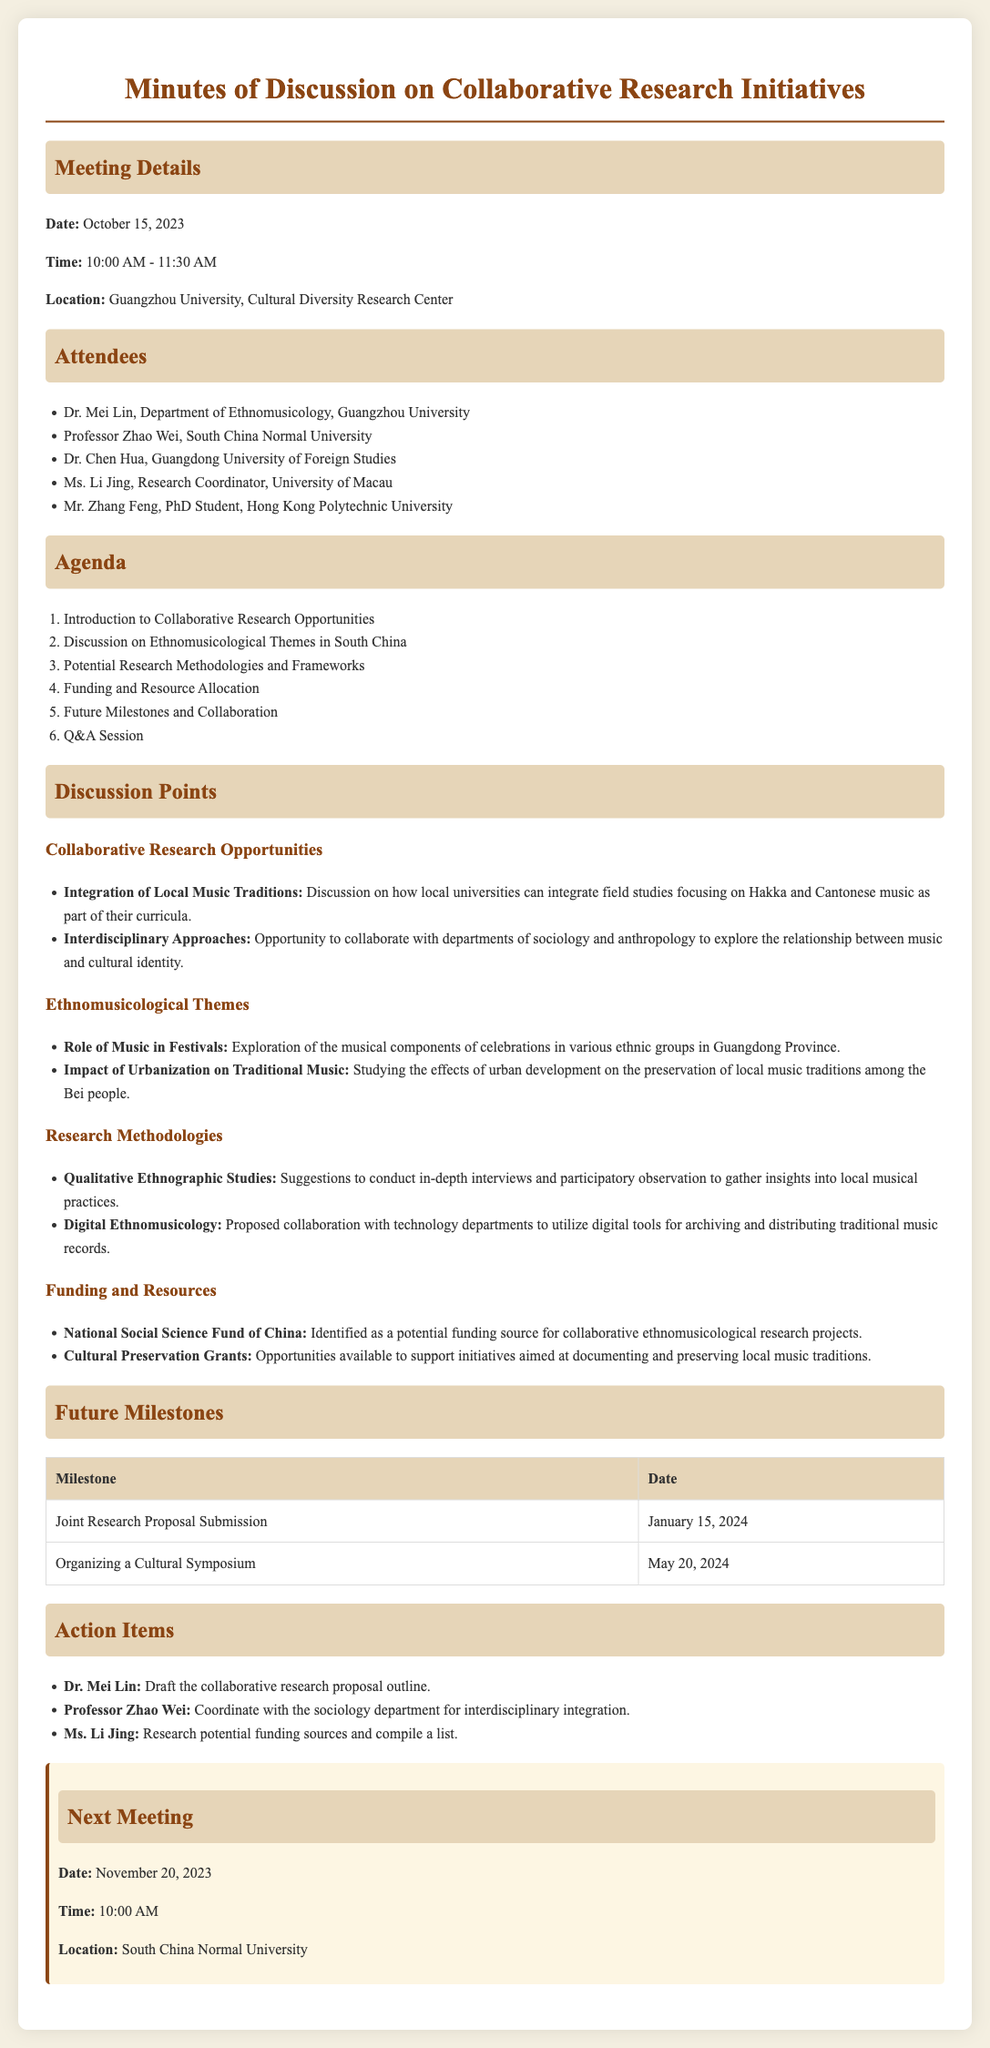What is the date of the meeting? The date is mentioned in the meeting details section of the document.
Answer: October 15, 2023 Who is the Research Coordinator at the University of Macau? This information can be found in the list of attendees.
Answer: Ms. Li Jing What is one theme discussed related to ethnomusicology? Themes are outlined in the discussion points section.
Answer: Role of Music in Festivals What is the proposed date for organizing a cultural symposium? The date is indicated in the future milestones table.
Answer: May 20, 2024 What is one potential funding source identified for research projects? This information appears in the funding and resources section.
Answer: National Social Science Fund of China What is Dr. Mei Lin's action item? The action items specify responsibilities assigned to individuals.
Answer: Draft the collaborative research proposal outline How long is the next meeting scheduled to last? The meeting time is specified along with its start time.
Answer: unspecified (since the duration isn't given) Which university's faculty member will coordinate with the sociology department? This is indicated in the action items with the corresponding attendee's name.
Answer: Professor Zhao Wei What time is the next meeting? The time is clearly listed in the next meeting section of the document.
Answer: 10:00 AM 